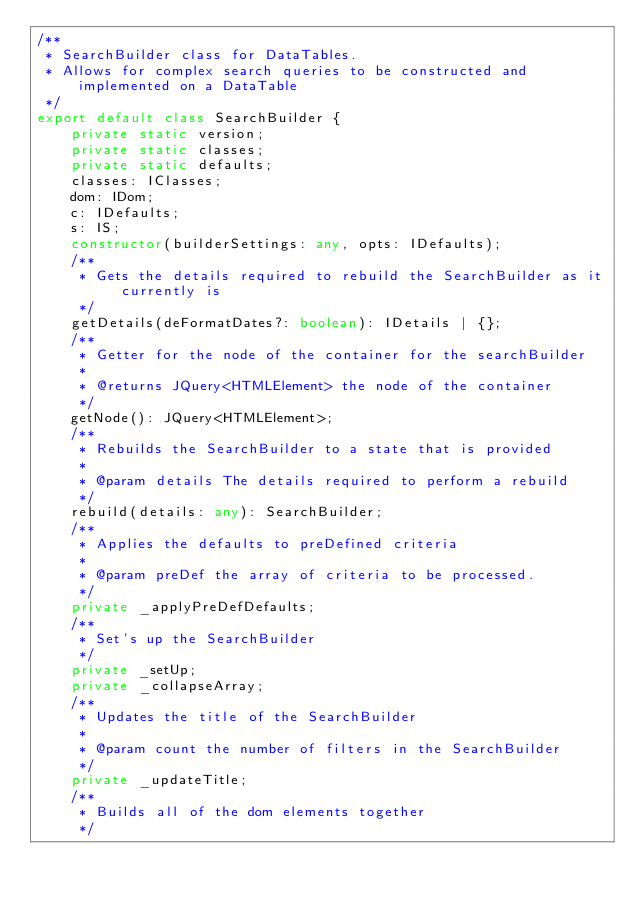<code> <loc_0><loc_0><loc_500><loc_500><_TypeScript_>/**
 * SearchBuilder class for DataTables.
 * Allows for complex search queries to be constructed and implemented on a DataTable
 */
export default class SearchBuilder {
    private static version;
    private static classes;
    private static defaults;
    classes: IClasses;
    dom: IDom;
    c: IDefaults;
    s: IS;
    constructor(builderSettings: any, opts: IDefaults);
    /**
     * Gets the details required to rebuild the SearchBuilder as it currently is
     */
    getDetails(deFormatDates?: boolean): IDetails | {};
    /**
     * Getter for the node of the container for the searchBuilder
     *
     * @returns JQuery<HTMLElement> the node of the container
     */
    getNode(): JQuery<HTMLElement>;
    /**
     * Rebuilds the SearchBuilder to a state that is provided
     *
     * @param details The details required to perform a rebuild
     */
    rebuild(details: any): SearchBuilder;
    /**
     * Applies the defaults to preDefined criteria
     *
     * @param preDef the array of criteria to be processed.
     */
    private _applyPreDefDefaults;
    /**
     * Set's up the SearchBuilder
     */
    private _setUp;
    private _collapseArray;
    /**
     * Updates the title of the SearchBuilder
     *
     * @param count the number of filters in the SearchBuilder
     */
    private _updateTitle;
    /**
     * Builds all of the dom elements together
     */</code> 